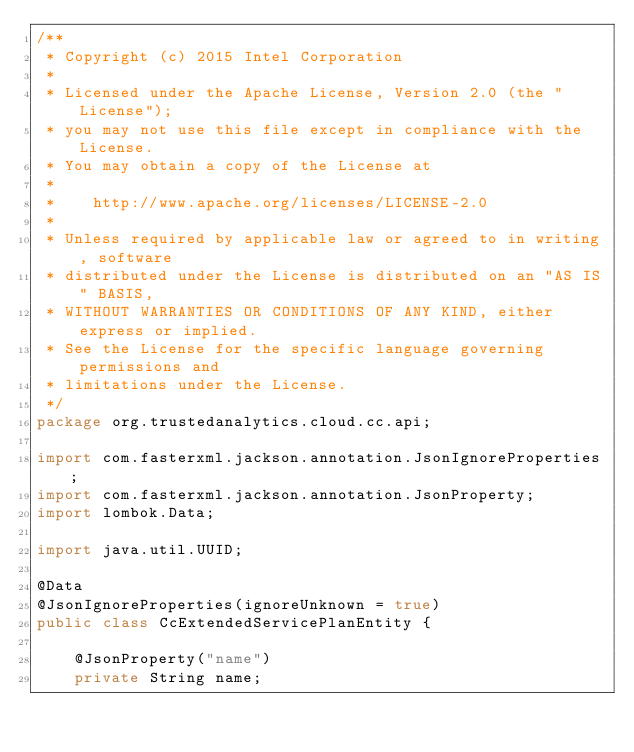<code> <loc_0><loc_0><loc_500><loc_500><_Java_>/**
 * Copyright (c) 2015 Intel Corporation
 *
 * Licensed under the Apache License, Version 2.0 (the "License");
 * you may not use this file except in compliance with the License.
 * You may obtain a copy of the License at
 *
 *    http://www.apache.org/licenses/LICENSE-2.0
 *
 * Unless required by applicable law or agreed to in writing, software
 * distributed under the License is distributed on an "AS IS" BASIS,
 * WITHOUT WARRANTIES OR CONDITIONS OF ANY KIND, either express or implied.
 * See the License for the specific language governing permissions and
 * limitations under the License.
 */
package org.trustedanalytics.cloud.cc.api;

import com.fasterxml.jackson.annotation.JsonIgnoreProperties;
import com.fasterxml.jackson.annotation.JsonProperty;
import lombok.Data;

import java.util.UUID;

@Data
@JsonIgnoreProperties(ignoreUnknown = true)
public class CcExtendedServicePlanEntity {

    @JsonProperty("name")
    private String name;
</code> 